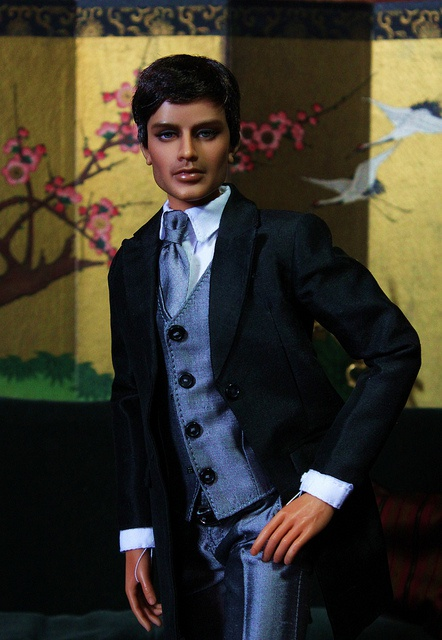Describe the objects in this image and their specific colors. I can see people in black, gray, brown, and navy tones, bird in black, gray, olive, and darkgray tones, tie in black, gray, darkgray, and navy tones, and bird in black, lightgray, and darkgray tones in this image. 